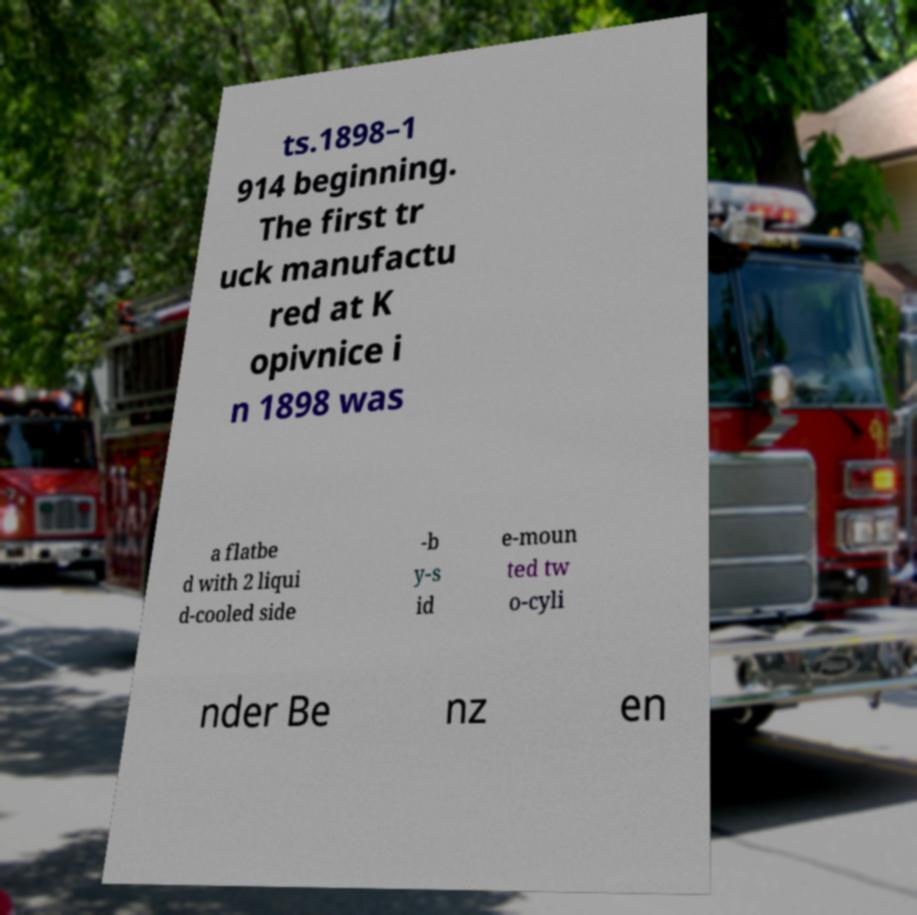Please identify and transcribe the text found in this image. ts.1898–1 914 beginning. The first tr uck manufactu red at K opivnice i n 1898 was a flatbe d with 2 liqui d-cooled side -b y-s id e-moun ted tw o-cyli nder Be nz en 